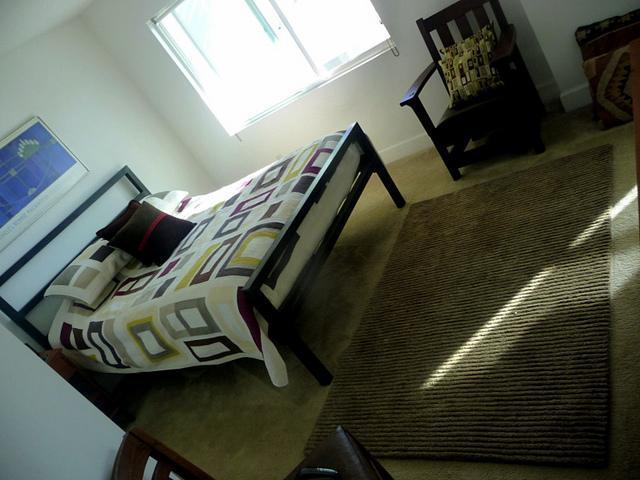How many chairs are in the picture?
Give a very brief answer. 2. 